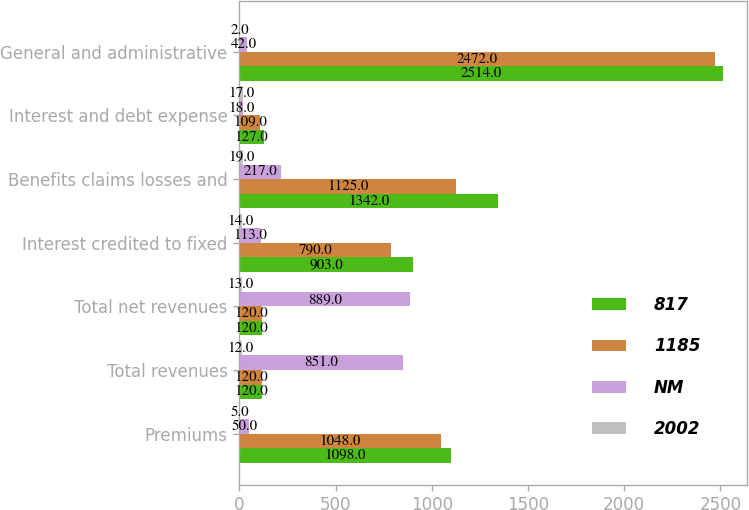Convert chart to OTSL. <chart><loc_0><loc_0><loc_500><loc_500><stacked_bar_chart><ecel><fcel>Premiums<fcel>Total revenues<fcel>Total net revenues<fcel>Interest credited to fixed<fcel>Benefits claims losses and<fcel>Interest and debt expense<fcel>General and administrative<nl><fcel>817<fcel>1098<fcel>120<fcel>120<fcel>903<fcel>1342<fcel>127<fcel>2514<nl><fcel>1185<fcel>1048<fcel>120<fcel>120<fcel>790<fcel>1125<fcel>109<fcel>2472<nl><fcel>NM<fcel>50<fcel>851<fcel>889<fcel>113<fcel>217<fcel>18<fcel>42<nl><fcel>2002<fcel>5<fcel>12<fcel>13<fcel>14<fcel>19<fcel>17<fcel>2<nl></chart> 